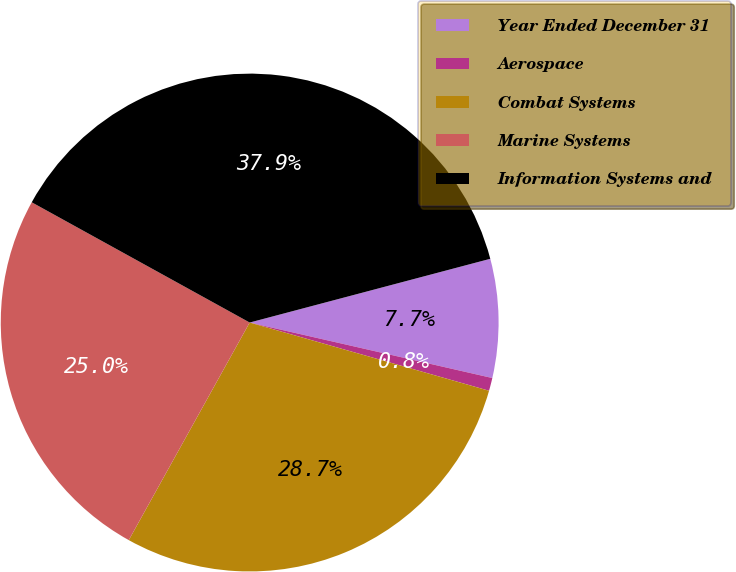Convert chart. <chart><loc_0><loc_0><loc_500><loc_500><pie_chart><fcel>Year Ended December 31<fcel>Aerospace<fcel>Combat Systems<fcel>Marine Systems<fcel>Information Systems and<nl><fcel>7.7%<fcel>0.84%<fcel>28.65%<fcel>24.95%<fcel>37.85%<nl></chart> 